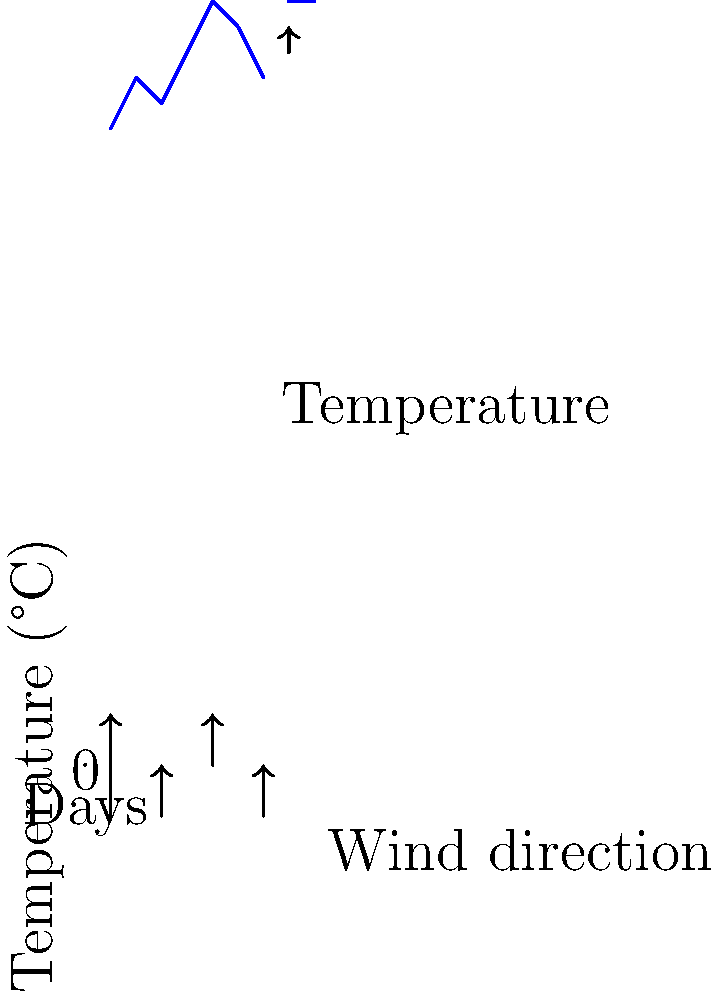As the tribal leader, you've been observing weather patterns to guide planting decisions. The graph shows temperature changes and wind directions over a week. On which day does the graph indicate the highest likelihood of rain, considering both temperature and wind direction? To determine the day with the highest likelihood of rain, we need to analyze both temperature trends and wind directions:

1. Temperature analysis:
   - A sudden drop in temperature often precedes rainfall.
   - The temperature rises from day 1 to day 5, then starts to decrease.

2. Wind direction analysis:
   - Upward arrows indicate winds from the south, which often bring moisture.
   - Downward arrows indicate winds from the north, which are typically drier.

3. Day-by-day analysis:
   - Day 1: Temperature low, wind from south
   - Day 2: Temperature rising, no wind data
   - Day 3: Temperature slight drop, wind from north
   - Day 4: Temperature rising, no wind data
   - Day 5: Highest temperature, wind from south
   - Day 6: Temperature dropping, no wind data
   - Day 7: Temperature continues to drop, wind from north

4. Conclusion:
   The combination of dropping temperature after a peak and winds from the south indicates the highest likelihood of rain. This occurs on day 6, where the temperature drops after the peak on day 5, and we can infer southerly winds based on the change from day 5 to day 7.
Answer: Day 6 